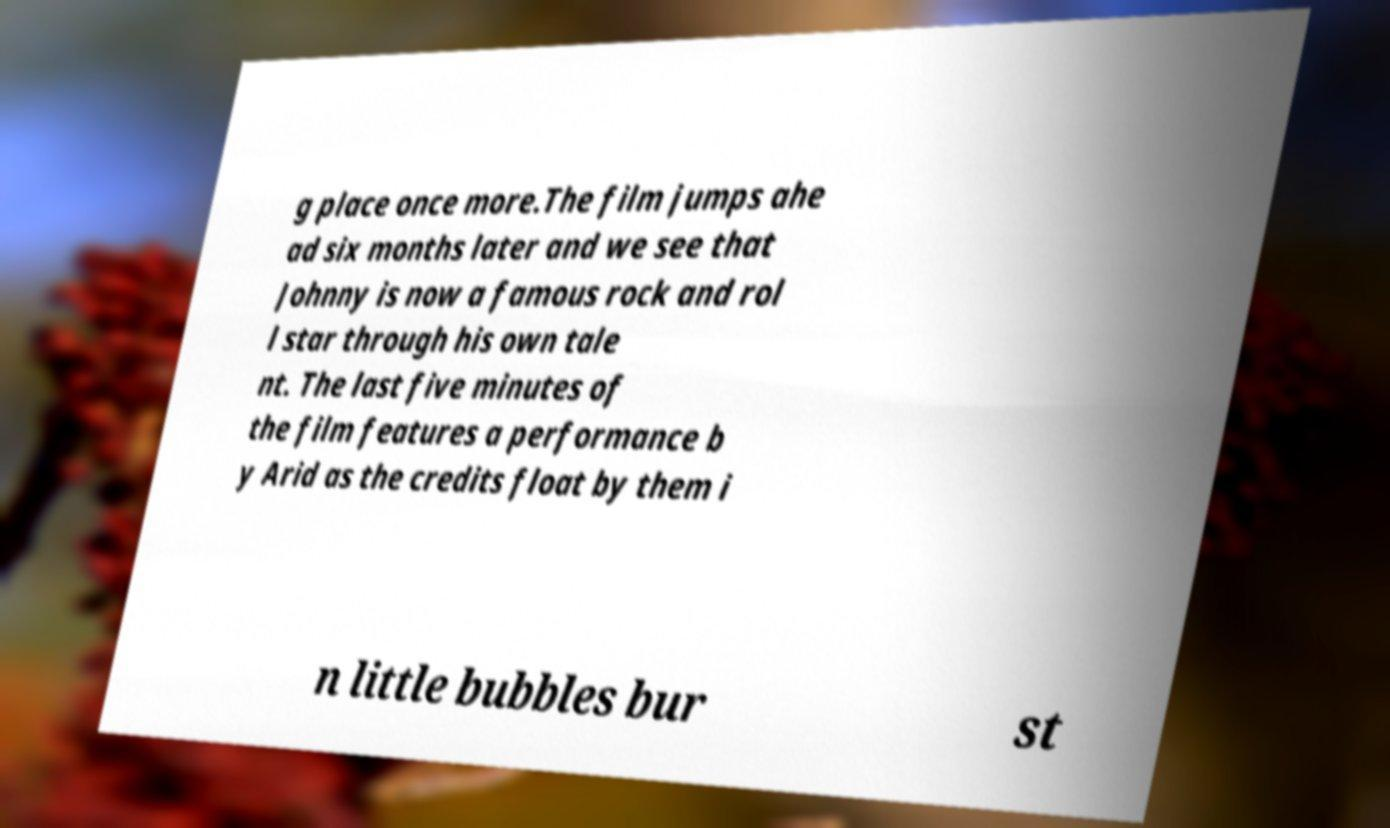What messages or text are displayed in this image? I need them in a readable, typed format. g place once more.The film jumps ahe ad six months later and we see that Johnny is now a famous rock and rol l star through his own tale nt. The last five minutes of the film features a performance b y Arid as the credits float by them i n little bubbles bur st 